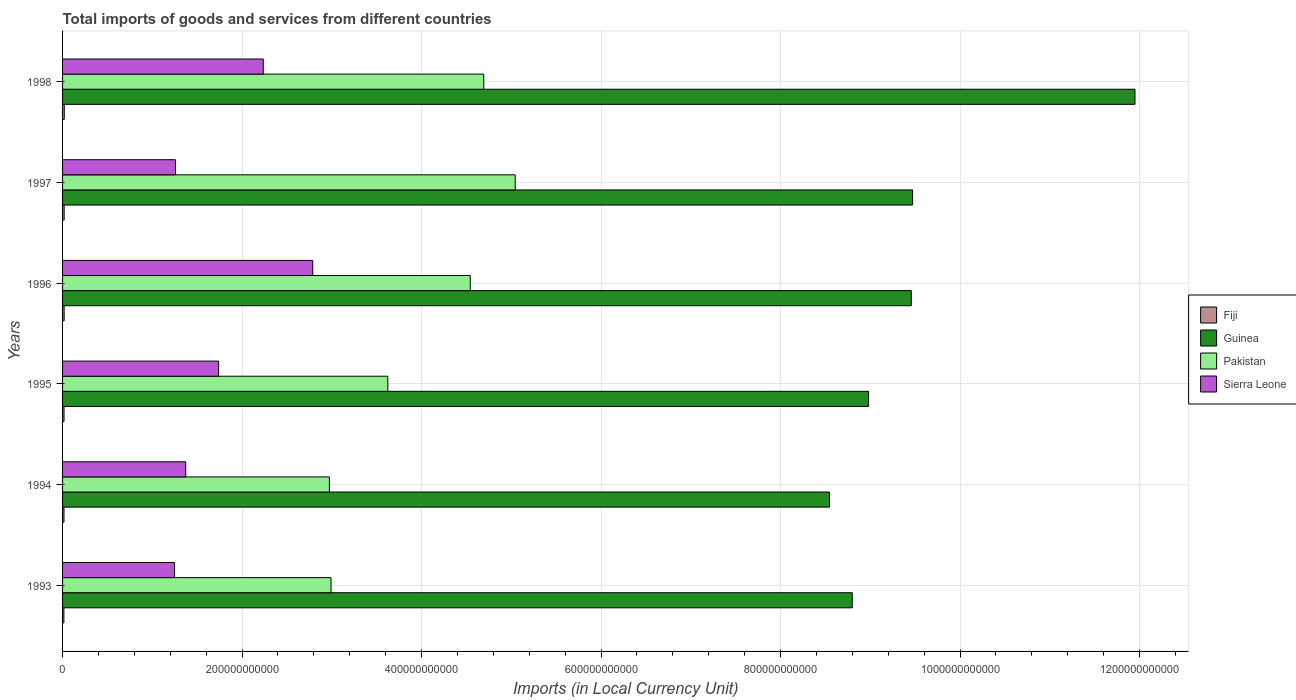How many different coloured bars are there?
Offer a terse response. 4. How many groups of bars are there?
Your response must be concise. 6. Are the number of bars per tick equal to the number of legend labels?
Offer a very short reply. Yes. Are the number of bars on each tick of the Y-axis equal?
Your answer should be compact. Yes. How many bars are there on the 1st tick from the bottom?
Make the answer very short. 4. What is the label of the 1st group of bars from the top?
Keep it short and to the point. 1998. In how many cases, is the number of bars for a given year not equal to the number of legend labels?
Keep it short and to the point. 0. What is the Amount of goods and services imports in Fiji in 1994?
Offer a very short reply. 1.59e+09. Across all years, what is the maximum Amount of goods and services imports in Sierra Leone?
Offer a very short reply. 2.79e+11. Across all years, what is the minimum Amount of goods and services imports in Sierra Leone?
Offer a terse response. 1.25e+11. What is the total Amount of goods and services imports in Pakistan in the graph?
Offer a terse response. 2.39e+12. What is the difference between the Amount of goods and services imports in Fiji in 1996 and that in 1998?
Provide a succinct answer. -1.61e+08. What is the difference between the Amount of goods and services imports in Pakistan in 1993 and the Amount of goods and services imports in Guinea in 1994?
Offer a very short reply. -5.55e+11. What is the average Amount of goods and services imports in Fiji per year?
Keep it short and to the point. 1.69e+09. In the year 1995, what is the difference between the Amount of goods and services imports in Fiji and Amount of goods and services imports in Guinea?
Make the answer very short. -8.96e+11. What is the ratio of the Amount of goods and services imports in Guinea in 1997 to that in 1998?
Offer a terse response. 0.79. Is the difference between the Amount of goods and services imports in Fiji in 1996 and 1998 greater than the difference between the Amount of goods and services imports in Guinea in 1996 and 1998?
Ensure brevity in your answer.  Yes. What is the difference between the highest and the second highest Amount of goods and services imports in Guinea?
Your answer should be very brief. 2.48e+11. What is the difference between the highest and the lowest Amount of goods and services imports in Guinea?
Ensure brevity in your answer.  3.40e+11. Is the sum of the Amount of goods and services imports in Pakistan in 1994 and 1995 greater than the maximum Amount of goods and services imports in Fiji across all years?
Offer a terse response. Yes. What does the 2nd bar from the top in 1994 represents?
Give a very brief answer. Pakistan. What does the 1st bar from the bottom in 1995 represents?
Offer a very short reply. Fiji. Are all the bars in the graph horizontal?
Ensure brevity in your answer.  Yes. How many years are there in the graph?
Your answer should be compact. 6. What is the difference between two consecutive major ticks on the X-axis?
Offer a very short reply. 2.00e+11. Does the graph contain any zero values?
Offer a very short reply. No. How many legend labels are there?
Provide a succinct answer. 4. How are the legend labels stacked?
Your response must be concise. Vertical. What is the title of the graph?
Ensure brevity in your answer.  Total imports of goods and services from different countries. What is the label or title of the X-axis?
Provide a short and direct response. Imports (in Local Currency Unit). What is the label or title of the Y-axis?
Provide a succinct answer. Years. What is the Imports (in Local Currency Unit) in Fiji in 1993?
Keep it short and to the point. 1.50e+09. What is the Imports (in Local Currency Unit) of Guinea in 1993?
Your response must be concise. 8.80e+11. What is the Imports (in Local Currency Unit) of Pakistan in 1993?
Keep it short and to the point. 2.99e+11. What is the Imports (in Local Currency Unit) in Sierra Leone in 1993?
Keep it short and to the point. 1.25e+11. What is the Imports (in Local Currency Unit) in Fiji in 1994?
Your response must be concise. 1.59e+09. What is the Imports (in Local Currency Unit) in Guinea in 1994?
Provide a short and direct response. 8.55e+11. What is the Imports (in Local Currency Unit) in Pakistan in 1994?
Your answer should be compact. 2.97e+11. What is the Imports (in Local Currency Unit) in Sierra Leone in 1994?
Your answer should be very brief. 1.37e+11. What is the Imports (in Local Currency Unit) of Fiji in 1995?
Give a very brief answer. 1.63e+09. What is the Imports (in Local Currency Unit) of Guinea in 1995?
Provide a short and direct response. 8.98e+11. What is the Imports (in Local Currency Unit) of Pakistan in 1995?
Your response must be concise. 3.62e+11. What is the Imports (in Local Currency Unit) of Sierra Leone in 1995?
Provide a succinct answer. 1.74e+11. What is the Imports (in Local Currency Unit) in Fiji in 1996?
Offer a very short reply. 1.76e+09. What is the Imports (in Local Currency Unit) in Guinea in 1996?
Provide a succinct answer. 9.46e+11. What is the Imports (in Local Currency Unit) of Pakistan in 1996?
Provide a succinct answer. 4.54e+11. What is the Imports (in Local Currency Unit) in Sierra Leone in 1996?
Your answer should be compact. 2.79e+11. What is the Imports (in Local Currency Unit) of Fiji in 1997?
Provide a succinct answer. 1.77e+09. What is the Imports (in Local Currency Unit) of Guinea in 1997?
Your answer should be compact. 9.47e+11. What is the Imports (in Local Currency Unit) of Pakistan in 1997?
Offer a terse response. 5.04e+11. What is the Imports (in Local Currency Unit) of Sierra Leone in 1997?
Provide a succinct answer. 1.26e+11. What is the Imports (in Local Currency Unit) in Fiji in 1998?
Provide a short and direct response. 1.92e+09. What is the Imports (in Local Currency Unit) in Guinea in 1998?
Your response must be concise. 1.19e+12. What is the Imports (in Local Currency Unit) in Pakistan in 1998?
Your answer should be very brief. 4.69e+11. What is the Imports (in Local Currency Unit) of Sierra Leone in 1998?
Your answer should be very brief. 2.24e+11. Across all years, what is the maximum Imports (in Local Currency Unit) in Fiji?
Keep it short and to the point. 1.92e+09. Across all years, what is the maximum Imports (in Local Currency Unit) of Guinea?
Provide a short and direct response. 1.19e+12. Across all years, what is the maximum Imports (in Local Currency Unit) in Pakistan?
Your response must be concise. 5.04e+11. Across all years, what is the maximum Imports (in Local Currency Unit) in Sierra Leone?
Keep it short and to the point. 2.79e+11. Across all years, what is the minimum Imports (in Local Currency Unit) in Fiji?
Your response must be concise. 1.50e+09. Across all years, what is the minimum Imports (in Local Currency Unit) of Guinea?
Your response must be concise. 8.55e+11. Across all years, what is the minimum Imports (in Local Currency Unit) of Pakistan?
Provide a short and direct response. 2.97e+11. Across all years, what is the minimum Imports (in Local Currency Unit) of Sierra Leone?
Your response must be concise. 1.25e+11. What is the total Imports (in Local Currency Unit) in Fiji in the graph?
Make the answer very short. 1.02e+1. What is the total Imports (in Local Currency Unit) of Guinea in the graph?
Your response must be concise. 5.72e+12. What is the total Imports (in Local Currency Unit) of Pakistan in the graph?
Provide a succinct answer. 2.39e+12. What is the total Imports (in Local Currency Unit) in Sierra Leone in the graph?
Make the answer very short. 1.06e+12. What is the difference between the Imports (in Local Currency Unit) in Fiji in 1993 and that in 1994?
Ensure brevity in your answer.  -8.98e+07. What is the difference between the Imports (in Local Currency Unit) in Guinea in 1993 and that in 1994?
Offer a very short reply. 2.54e+1. What is the difference between the Imports (in Local Currency Unit) in Pakistan in 1993 and that in 1994?
Offer a terse response. 1.84e+09. What is the difference between the Imports (in Local Currency Unit) of Sierra Leone in 1993 and that in 1994?
Your response must be concise. -1.25e+1. What is the difference between the Imports (in Local Currency Unit) of Fiji in 1993 and that in 1995?
Offer a terse response. -1.32e+08. What is the difference between the Imports (in Local Currency Unit) in Guinea in 1993 and that in 1995?
Provide a succinct answer. -1.82e+1. What is the difference between the Imports (in Local Currency Unit) in Pakistan in 1993 and that in 1995?
Provide a short and direct response. -6.33e+1. What is the difference between the Imports (in Local Currency Unit) in Sierra Leone in 1993 and that in 1995?
Provide a short and direct response. -4.92e+1. What is the difference between the Imports (in Local Currency Unit) of Fiji in 1993 and that in 1996?
Your response must be concise. -2.59e+08. What is the difference between the Imports (in Local Currency Unit) in Guinea in 1993 and that in 1996?
Your response must be concise. -6.58e+1. What is the difference between the Imports (in Local Currency Unit) in Pakistan in 1993 and that in 1996?
Provide a succinct answer. -1.55e+11. What is the difference between the Imports (in Local Currency Unit) of Sierra Leone in 1993 and that in 1996?
Your answer should be compact. -1.54e+11. What is the difference between the Imports (in Local Currency Unit) of Fiji in 1993 and that in 1997?
Make the answer very short. -2.68e+08. What is the difference between the Imports (in Local Currency Unit) in Guinea in 1993 and that in 1997?
Your answer should be compact. -6.72e+1. What is the difference between the Imports (in Local Currency Unit) of Pakistan in 1993 and that in 1997?
Your response must be concise. -2.05e+11. What is the difference between the Imports (in Local Currency Unit) of Sierra Leone in 1993 and that in 1997?
Ensure brevity in your answer.  -1.14e+09. What is the difference between the Imports (in Local Currency Unit) in Fiji in 1993 and that in 1998?
Your answer should be very brief. -4.20e+08. What is the difference between the Imports (in Local Currency Unit) in Guinea in 1993 and that in 1998?
Your answer should be very brief. -3.15e+11. What is the difference between the Imports (in Local Currency Unit) of Pakistan in 1993 and that in 1998?
Offer a very short reply. -1.70e+11. What is the difference between the Imports (in Local Currency Unit) of Sierra Leone in 1993 and that in 1998?
Your answer should be compact. -9.89e+1. What is the difference between the Imports (in Local Currency Unit) of Fiji in 1994 and that in 1995?
Give a very brief answer. -4.18e+07. What is the difference between the Imports (in Local Currency Unit) in Guinea in 1994 and that in 1995?
Your answer should be very brief. -4.36e+1. What is the difference between the Imports (in Local Currency Unit) in Pakistan in 1994 and that in 1995?
Provide a short and direct response. -6.51e+1. What is the difference between the Imports (in Local Currency Unit) of Sierra Leone in 1994 and that in 1995?
Your response must be concise. -3.66e+1. What is the difference between the Imports (in Local Currency Unit) in Fiji in 1994 and that in 1996?
Offer a terse response. -1.70e+08. What is the difference between the Imports (in Local Currency Unit) of Guinea in 1994 and that in 1996?
Give a very brief answer. -9.12e+1. What is the difference between the Imports (in Local Currency Unit) in Pakistan in 1994 and that in 1996?
Offer a terse response. -1.57e+11. What is the difference between the Imports (in Local Currency Unit) of Sierra Leone in 1994 and that in 1996?
Make the answer very short. -1.42e+11. What is the difference between the Imports (in Local Currency Unit) in Fiji in 1994 and that in 1997?
Make the answer very short. -1.78e+08. What is the difference between the Imports (in Local Currency Unit) in Guinea in 1994 and that in 1997?
Keep it short and to the point. -9.26e+1. What is the difference between the Imports (in Local Currency Unit) of Pakistan in 1994 and that in 1997?
Your response must be concise. -2.07e+11. What is the difference between the Imports (in Local Currency Unit) in Sierra Leone in 1994 and that in 1997?
Make the answer very short. 1.14e+1. What is the difference between the Imports (in Local Currency Unit) in Fiji in 1994 and that in 1998?
Your answer should be compact. -3.30e+08. What is the difference between the Imports (in Local Currency Unit) in Guinea in 1994 and that in 1998?
Your answer should be compact. -3.40e+11. What is the difference between the Imports (in Local Currency Unit) in Pakistan in 1994 and that in 1998?
Offer a very short reply. -1.72e+11. What is the difference between the Imports (in Local Currency Unit) of Sierra Leone in 1994 and that in 1998?
Make the answer very short. -8.64e+1. What is the difference between the Imports (in Local Currency Unit) in Fiji in 1995 and that in 1996?
Make the answer very short. -1.28e+08. What is the difference between the Imports (in Local Currency Unit) in Guinea in 1995 and that in 1996?
Make the answer very short. -4.76e+1. What is the difference between the Imports (in Local Currency Unit) of Pakistan in 1995 and that in 1996?
Offer a terse response. -9.19e+1. What is the difference between the Imports (in Local Currency Unit) of Sierra Leone in 1995 and that in 1996?
Offer a very short reply. -1.05e+11. What is the difference between the Imports (in Local Currency Unit) in Fiji in 1995 and that in 1997?
Your answer should be compact. -1.36e+08. What is the difference between the Imports (in Local Currency Unit) in Guinea in 1995 and that in 1997?
Provide a short and direct response. -4.90e+1. What is the difference between the Imports (in Local Currency Unit) of Pakistan in 1995 and that in 1997?
Offer a terse response. -1.42e+11. What is the difference between the Imports (in Local Currency Unit) in Sierra Leone in 1995 and that in 1997?
Your answer should be very brief. 4.80e+1. What is the difference between the Imports (in Local Currency Unit) of Fiji in 1995 and that in 1998?
Your answer should be compact. -2.89e+08. What is the difference between the Imports (in Local Currency Unit) of Guinea in 1995 and that in 1998?
Provide a short and direct response. -2.97e+11. What is the difference between the Imports (in Local Currency Unit) in Pakistan in 1995 and that in 1998?
Give a very brief answer. -1.07e+11. What is the difference between the Imports (in Local Currency Unit) of Sierra Leone in 1995 and that in 1998?
Your answer should be compact. -4.98e+1. What is the difference between the Imports (in Local Currency Unit) of Fiji in 1996 and that in 1997?
Keep it short and to the point. -8.40e+06. What is the difference between the Imports (in Local Currency Unit) in Guinea in 1996 and that in 1997?
Offer a very short reply. -1.47e+09. What is the difference between the Imports (in Local Currency Unit) of Pakistan in 1996 and that in 1997?
Your answer should be very brief. -5.01e+1. What is the difference between the Imports (in Local Currency Unit) of Sierra Leone in 1996 and that in 1997?
Provide a succinct answer. 1.53e+11. What is the difference between the Imports (in Local Currency Unit) in Fiji in 1996 and that in 1998?
Keep it short and to the point. -1.61e+08. What is the difference between the Imports (in Local Currency Unit) in Guinea in 1996 and that in 1998?
Your response must be concise. -2.49e+11. What is the difference between the Imports (in Local Currency Unit) in Pakistan in 1996 and that in 1998?
Keep it short and to the point. -1.50e+1. What is the difference between the Imports (in Local Currency Unit) in Sierra Leone in 1996 and that in 1998?
Give a very brief answer. 5.51e+1. What is the difference between the Imports (in Local Currency Unit) of Fiji in 1997 and that in 1998?
Provide a succinct answer. -1.52e+08. What is the difference between the Imports (in Local Currency Unit) in Guinea in 1997 and that in 1998?
Offer a very short reply. -2.48e+11. What is the difference between the Imports (in Local Currency Unit) of Pakistan in 1997 and that in 1998?
Ensure brevity in your answer.  3.51e+1. What is the difference between the Imports (in Local Currency Unit) in Sierra Leone in 1997 and that in 1998?
Ensure brevity in your answer.  -9.78e+1. What is the difference between the Imports (in Local Currency Unit) of Fiji in 1993 and the Imports (in Local Currency Unit) of Guinea in 1994?
Give a very brief answer. -8.53e+11. What is the difference between the Imports (in Local Currency Unit) of Fiji in 1993 and the Imports (in Local Currency Unit) of Pakistan in 1994?
Your answer should be very brief. -2.96e+11. What is the difference between the Imports (in Local Currency Unit) in Fiji in 1993 and the Imports (in Local Currency Unit) in Sierra Leone in 1994?
Keep it short and to the point. -1.36e+11. What is the difference between the Imports (in Local Currency Unit) in Guinea in 1993 and the Imports (in Local Currency Unit) in Pakistan in 1994?
Ensure brevity in your answer.  5.83e+11. What is the difference between the Imports (in Local Currency Unit) in Guinea in 1993 and the Imports (in Local Currency Unit) in Sierra Leone in 1994?
Your response must be concise. 7.43e+11. What is the difference between the Imports (in Local Currency Unit) in Pakistan in 1993 and the Imports (in Local Currency Unit) in Sierra Leone in 1994?
Your response must be concise. 1.62e+11. What is the difference between the Imports (in Local Currency Unit) in Fiji in 1993 and the Imports (in Local Currency Unit) in Guinea in 1995?
Provide a succinct answer. -8.97e+11. What is the difference between the Imports (in Local Currency Unit) in Fiji in 1993 and the Imports (in Local Currency Unit) in Pakistan in 1995?
Provide a succinct answer. -3.61e+11. What is the difference between the Imports (in Local Currency Unit) in Fiji in 1993 and the Imports (in Local Currency Unit) in Sierra Leone in 1995?
Make the answer very short. -1.72e+11. What is the difference between the Imports (in Local Currency Unit) in Guinea in 1993 and the Imports (in Local Currency Unit) in Pakistan in 1995?
Your response must be concise. 5.17e+11. What is the difference between the Imports (in Local Currency Unit) in Guinea in 1993 and the Imports (in Local Currency Unit) in Sierra Leone in 1995?
Your answer should be compact. 7.06e+11. What is the difference between the Imports (in Local Currency Unit) in Pakistan in 1993 and the Imports (in Local Currency Unit) in Sierra Leone in 1995?
Make the answer very short. 1.25e+11. What is the difference between the Imports (in Local Currency Unit) in Fiji in 1993 and the Imports (in Local Currency Unit) in Guinea in 1996?
Give a very brief answer. -9.44e+11. What is the difference between the Imports (in Local Currency Unit) of Fiji in 1993 and the Imports (in Local Currency Unit) of Pakistan in 1996?
Offer a terse response. -4.53e+11. What is the difference between the Imports (in Local Currency Unit) of Fiji in 1993 and the Imports (in Local Currency Unit) of Sierra Leone in 1996?
Provide a short and direct response. -2.77e+11. What is the difference between the Imports (in Local Currency Unit) of Guinea in 1993 and the Imports (in Local Currency Unit) of Pakistan in 1996?
Your answer should be very brief. 4.26e+11. What is the difference between the Imports (in Local Currency Unit) in Guinea in 1993 and the Imports (in Local Currency Unit) in Sierra Leone in 1996?
Provide a succinct answer. 6.01e+11. What is the difference between the Imports (in Local Currency Unit) of Pakistan in 1993 and the Imports (in Local Currency Unit) of Sierra Leone in 1996?
Give a very brief answer. 2.04e+1. What is the difference between the Imports (in Local Currency Unit) of Fiji in 1993 and the Imports (in Local Currency Unit) of Guinea in 1997?
Your answer should be very brief. -9.46e+11. What is the difference between the Imports (in Local Currency Unit) of Fiji in 1993 and the Imports (in Local Currency Unit) of Pakistan in 1997?
Keep it short and to the point. -5.03e+11. What is the difference between the Imports (in Local Currency Unit) in Fiji in 1993 and the Imports (in Local Currency Unit) in Sierra Leone in 1997?
Give a very brief answer. -1.24e+11. What is the difference between the Imports (in Local Currency Unit) in Guinea in 1993 and the Imports (in Local Currency Unit) in Pakistan in 1997?
Offer a very short reply. 3.76e+11. What is the difference between the Imports (in Local Currency Unit) of Guinea in 1993 and the Imports (in Local Currency Unit) of Sierra Leone in 1997?
Keep it short and to the point. 7.54e+11. What is the difference between the Imports (in Local Currency Unit) in Pakistan in 1993 and the Imports (in Local Currency Unit) in Sierra Leone in 1997?
Keep it short and to the point. 1.73e+11. What is the difference between the Imports (in Local Currency Unit) of Fiji in 1993 and the Imports (in Local Currency Unit) of Guinea in 1998?
Keep it short and to the point. -1.19e+12. What is the difference between the Imports (in Local Currency Unit) in Fiji in 1993 and the Imports (in Local Currency Unit) in Pakistan in 1998?
Offer a very short reply. -4.68e+11. What is the difference between the Imports (in Local Currency Unit) of Fiji in 1993 and the Imports (in Local Currency Unit) of Sierra Leone in 1998?
Give a very brief answer. -2.22e+11. What is the difference between the Imports (in Local Currency Unit) of Guinea in 1993 and the Imports (in Local Currency Unit) of Pakistan in 1998?
Your answer should be compact. 4.11e+11. What is the difference between the Imports (in Local Currency Unit) in Guinea in 1993 and the Imports (in Local Currency Unit) in Sierra Leone in 1998?
Offer a terse response. 6.56e+11. What is the difference between the Imports (in Local Currency Unit) of Pakistan in 1993 and the Imports (in Local Currency Unit) of Sierra Leone in 1998?
Your answer should be very brief. 7.55e+1. What is the difference between the Imports (in Local Currency Unit) in Fiji in 1994 and the Imports (in Local Currency Unit) in Guinea in 1995?
Keep it short and to the point. -8.97e+11. What is the difference between the Imports (in Local Currency Unit) of Fiji in 1994 and the Imports (in Local Currency Unit) of Pakistan in 1995?
Offer a terse response. -3.61e+11. What is the difference between the Imports (in Local Currency Unit) in Fiji in 1994 and the Imports (in Local Currency Unit) in Sierra Leone in 1995?
Provide a succinct answer. -1.72e+11. What is the difference between the Imports (in Local Currency Unit) of Guinea in 1994 and the Imports (in Local Currency Unit) of Pakistan in 1995?
Provide a succinct answer. 4.92e+11. What is the difference between the Imports (in Local Currency Unit) of Guinea in 1994 and the Imports (in Local Currency Unit) of Sierra Leone in 1995?
Your answer should be very brief. 6.81e+11. What is the difference between the Imports (in Local Currency Unit) of Pakistan in 1994 and the Imports (in Local Currency Unit) of Sierra Leone in 1995?
Your response must be concise. 1.23e+11. What is the difference between the Imports (in Local Currency Unit) in Fiji in 1994 and the Imports (in Local Currency Unit) in Guinea in 1996?
Keep it short and to the point. -9.44e+11. What is the difference between the Imports (in Local Currency Unit) of Fiji in 1994 and the Imports (in Local Currency Unit) of Pakistan in 1996?
Offer a very short reply. -4.53e+11. What is the difference between the Imports (in Local Currency Unit) in Fiji in 1994 and the Imports (in Local Currency Unit) in Sierra Leone in 1996?
Make the answer very short. -2.77e+11. What is the difference between the Imports (in Local Currency Unit) of Guinea in 1994 and the Imports (in Local Currency Unit) of Pakistan in 1996?
Your answer should be compact. 4.00e+11. What is the difference between the Imports (in Local Currency Unit) in Guinea in 1994 and the Imports (in Local Currency Unit) in Sierra Leone in 1996?
Your answer should be compact. 5.76e+11. What is the difference between the Imports (in Local Currency Unit) of Pakistan in 1994 and the Imports (in Local Currency Unit) of Sierra Leone in 1996?
Make the answer very short. 1.85e+1. What is the difference between the Imports (in Local Currency Unit) in Fiji in 1994 and the Imports (in Local Currency Unit) in Guinea in 1997?
Offer a very short reply. -9.46e+11. What is the difference between the Imports (in Local Currency Unit) of Fiji in 1994 and the Imports (in Local Currency Unit) of Pakistan in 1997?
Provide a short and direct response. -5.03e+11. What is the difference between the Imports (in Local Currency Unit) of Fiji in 1994 and the Imports (in Local Currency Unit) of Sierra Leone in 1997?
Give a very brief answer. -1.24e+11. What is the difference between the Imports (in Local Currency Unit) of Guinea in 1994 and the Imports (in Local Currency Unit) of Pakistan in 1997?
Ensure brevity in your answer.  3.50e+11. What is the difference between the Imports (in Local Currency Unit) in Guinea in 1994 and the Imports (in Local Currency Unit) in Sierra Leone in 1997?
Your response must be concise. 7.29e+11. What is the difference between the Imports (in Local Currency Unit) in Pakistan in 1994 and the Imports (in Local Currency Unit) in Sierra Leone in 1997?
Offer a very short reply. 1.71e+11. What is the difference between the Imports (in Local Currency Unit) of Fiji in 1994 and the Imports (in Local Currency Unit) of Guinea in 1998?
Offer a terse response. -1.19e+12. What is the difference between the Imports (in Local Currency Unit) of Fiji in 1994 and the Imports (in Local Currency Unit) of Pakistan in 1998?
Give a very brief answer. -4.68e+11. What is the difference between the Imports (in Local Currency Unit) of Fiji in 1994 and the Imports (in Local Currency Unit) of Sierra Leone in 1998?
Offer a very short reply. -2.22e+11. What is the difference between the Imports (in Local Currency Unit) of Guinea in 1994 and the Imports (in Local Currency Unit) of Pakistan in 1998?
Offer a very short reply. 3.85e+11. What is the difference between the Imports (in Local Currency Unit) in Guinea in 1994 and the Imports (in Local Currency Unit) in Sierra Leone in 1998?
Your response must be concise. 6.31e+11. What is the difference between the Imports (in Local Currency Unit) in Pakistan in 1994 and the Imports (in Local Currency Unit) in Sierra Leone in 1998?
Give a very brief answer. 7.37e+1. What is the difference between the Imports (in Local Currency Unit) of Fiji in 1995 and the Imports (in Local Currency Unit) of Guinea in 1996?
Your response must be concise. -9.44e+11. What is the difference between the Imports (in Local Currency Unit) in Fiji in 1995 and the Imports (in Local Currency Unit) in Pakistan in 1996?
Make the answer very short. -4.53e+11. What is the difference between the Imports (in Local Currency Unit) in Fiji in 1995 and the Imports (in Local Currency Unit) in Sierra Leone in 1996?
Offer a terse response. -2.77e+11. What is the difference between the Imports (in Local Currency Unit) in Guinea in 1995 and the Imports (in Local Currency Unit) in Pakistan in 1996?
Offer a very short reply. 4.44e+11. What is the difference between the Imports (in Local Currency Unit) of Guinea in 1995 and the Imports (in Local Currency Unit) of Sierra Leone in 1996?
Ensure brevity in your answer.  6.19e+11. What is the difference between the Imports (in Local Currency Unit) in Pakistan in 1995 and the Imports (in Local Currency Unit) in Sierra Leone in 1996?
Offer a very short reply. 8.37e+1. What is the difference between the Imports (in Local Currency Unit) of Fiji in 1995 and the Imports (in Local Currency Unit) of Guinea in 1997?
Your response must be concise. -9.46e+11. What is the difference between the Imports (in Local Currency Unit) in Fiji in 1995 and the Imports (in Local Currency Unit) in Pakistan in 1997?
Ensure brevity in your answer.  -5.03e+11. What is the difference between the Imports (in Local Currency Unit) of Fiji in 1995 and the Imports (in Local Currency Unit) of Sierra Leone in 1997?
Give a very brief answer. -1.24e+11. What is the difference between the Imports (in Local Currency Unit) in Guinea in 1995 and the Imports (in Local Currency Unit) in Pakistan in 1997?
Provide a short and direct response. 3.94e+11. What is the difference between the Imports (in Local Currency Unit) in Guinea in 1995 and the Imports (in Local Currency Unit) in Sierra Leone in 1997?
Keep it short and to the point. 7.72e+11. What is the difference between the Imports (in Local Currency Unit) of Pakistan in 1995 and the Imports (in Local Currency Unit) of Sierra Leone in 1997?
Ensure brevity in your answer.  2.37e+11. What is the difference between the Imports (in Local Currency Unit) of Fiji in 1995 and the Imports (in Local Currency Unit) of Guinea in 1998?
Keep it short and to the point. -1.19e+12. What is the difference between the Imports (in Local Currency Unit) in Fiji in 1995 and the Imports (in Local Currency Unit) in Pakistan in 1998?
Provide a succinct answer. -4.68e+11. What is the difference between the Imports (in Local Currency Unit) of Fiji in 1995 and the Imports (in Local Currency Unit) of Sierra Leone in 1998?
Ensure brevity in your answer.  -2.22e+11. What is the difference between the Imports (in Local Currency Unit) in Guinea in 1995 and the Imports (in Local Currency Unit) in Pakistan in 1998?
Give a very brief answer. 4.29e+11. What is the difference between the Imports (in Local Currency Unit) of Guinea in 1995 and the Imports (in Local Currency Unit) of Sierra Leone in 1998?
Offer a very short reply. 6.74e+11. What is the difference between the Imports (in Local Currency Unit) in Pakistan in 1995 and the Imports (in Local Currency Unit) in Sierra Leone in 1998?
Ensure brevity in your answer.  1.39e+11. What is the difference between the Imports (in Local Currency Unit) in Fiji in 1996 and the Imports (in Local Currency Unit) in Guinea in 1997?
Keep it short and to the point. -9.45e+11. What is the difference between the Imports (in Local Currency Unit) in Fiji in 1996 and the Imports (in Local Currency Unit) in Pakistan in 1997?
Your answer should be very brief. -5.03e+11. What is the difference between the Imports (in Local Currency Unit) in Fiji in 1996 and the Imports (in Local Currency Unit) in Sierra Leone in 1997?
Provide a succinct answer. -1.24e+11. What is the difference between the Imports (in Local Currency Unit) in Guinea in 1996 and the Imports (in Local Currency Unit) in Pakistan in 1997?
Provide a short and direct response. 4.41e+11. What is the difference between the Imports (in Local Currency Unit) in Guinea in 1996 and the Imports (in Local Currency Unit) in Sierra Leone in 1997?
Offer a terse response. 8.20e+11. What is the difference between the Imports (in Local Currency Unit) of Pakistan in 1996 and the Imports (in Local Currency Unit) of Sierra Leone in 1997?
Your answer should be very brief. 3.28e+11. What is the difference between the Imports (in Local Currency Unit) of Fiji in 1996 and the Imports (in Local Currency Unit) of Guinea in 1998?
Ensure brevity in your answer.  -1.19e+12. What is the difference between the Imports (in Local Currency Unit) in Fiji in 1996 and the Imports (in Local Currency Unit) in Pakistan in 1998?
Provide a short and direct response. -4.68e+11. What is the difference between the Imports (in Local Currency Unit) in Fiji in 1996 and the Imports (in Local Currency Unit) in Sierra Leone in 1998?
Keep it short and to the point. -2.22e+11. What is the difference between the Imports (in Local Currency Unit) of Guinea in 1996 and the Imports (in Local Currency Unit) of Pakistan in 1998?
Ensure brevity in your answer.  4.76e+11. What is the difference between the Imports (in Local Currency Unit) of Guinea in 1996 and the Imports (in Local Currency Unit) of Sierra Leone in 1998?
Keep it short and to the point. 7.22e+11. What is the difference between the Imports (in Local Currency Unit) of Pakistan in 1996 and the Imports (in Local Currency Unit) of Sierra Leone in 1998?
Give a very brief answer. 2.31e+11. What is the difference between the Imports (in Local Currency Unit) of Fiji in 1997 and the Imports (in Local Currency Unit) of Guinea in 1998?
Give a very brief answer. -1.19e+12. What is the difference between the Imports (in Local Currency Unit) in Fiji in 1997 and the Imports (in Local Currency Unit) in Pakistan in 1998?
Your answer should be compact. -4.68e+11. What is the difference between the Imports (in Local Currency Unit) in Fiji in 1997 and the Imports (in Local Currency Unit) in Sierra Leone in 1998?
Offer a very short reply. -2.22e+11. What is the difference between the Imports (in Local Currency Unit) in Guinea in 1997 and the Imports (in Local Currency Unit) in Pakistan in 1998?
Your response must be concise. 4.78e+11. What is the difference between the Imports (in Local Currency Unit) of Guinea in 1997 and the Imports (in Local Currency Unit) of Sierra Leone in 1998?
Your response must be concise. 7.24e+11. What is the difference between the Imports (in Local Currency Unit) in Pakistan in 1997 and the Imports (in Local Currency Unit) in Sierra Leone in 1998?
Make the answer very short. 2.81e+11. What is the average Imports (in Local Currency Unit) in Fiji per year?
Keep it short and to the point. 1.69e+09. What is the average Imports (in Local Currency Unit) of Guinea per year?
Ensure brevity in your answer.  9.53e+11. What is the average Imports (in Local Currency Unit) in Pakistan per year?
Provide a succinct answer. 3.98e+11. What is the average Imports (in Local Currency Unit) of Sierra Leone per year?
Offer a very short reply. 1.77e+11. In the year 1993, what is the difference between the Imports (in Local Currency Unit) in Fiji and Imports (in Local Currency Unit) in Guinea?
Provide a short and direct response. -8.78e+11. In the year 1993, what is the difference between the Imports (in Local Currency Unit) in Fiji and Imports (in Local Currency Unit) in Pakistan?
Your response must be concise. -2.98e+11. In the year 1993, what is the difference between the Imports (in Local Currency Unit) of Fiji and Imports (in Local Currency Unit) of Sierra Leone?
Keep it short and to the point. -1.23e+11. In the year 1993, what is the difference between the Imports (in Local Currency Unit) in Guinea and Imports (in Local Currency Unit) in Pakistan?
Make the answer very short. 5.81e+11. In the year 1993, what is the difference between the Imports (in Local Currency Unit) in Guinea and Imports (in Local Currency Unit) in Sierra Leone?
Ensure brevity in your answer.  7.55e+11. In the year 1993, what is the difference between the Imports (in Local Currency Unit) of Pakistan and Imports (in Local Currency Unit) of Sierra Leone?
Your answer should be compact. 1.74e+11. In the year 1994, what is the difference between the Imports (in Local Currency Unit) of Fiji and Imports (in Local Currency Unit) of Guinea?
Ensure brevity in your answer.  -8.53e+11. In the year 1994, what is the difference between the Imports (in Local Currency Unit) in Fiji and Imports (in Local Currency Unit) in Pakistan?
Your answer should be compact. -2.96e+11. In the year 1994, what is the difference between the Imports (in Local Currency Unit) of Fiji and Imports (in Local Currency Unit) of Sierra Leone?
Your answer should be compact. -1.36e+11. In the year 1994, what is the difference between the Imports (in Local Currency Unit) in Guinea and Imports (in Local Currency Unit) in Pakistan?
Your answer should be compact. 5.57e+11. In the year 1994, what is the difference between the Imports (in Local Currency Unit) of Guinea and Imports (in Local Currency Unit) of Sierra Leone?
Provide a short and direct response. 7.17e+11. In the year 1994, what is the difference between the Imports (in Local Currency Unit) of Pakistan and Imports (in Local Currency Unit) of Sierra Leone?
Offer a terse response. 1.60e+11. In the year 1995, what is the difference between the Imports (in Local Currency Unit) of Fiji and Imports (in Local Currency Unit) of Guinea?
Keep it short and to the point. -8.96e+11. In the year 1995, what is the difference between the Imports (in Local Currency Unit) of Fiji and Imports (in Local Currency Unit) of Pakistan?
Provide a short and direct response. -3.61e+11. In the year 1995, what is the difference between the Imports (in Local Currency Unit) of Fiji and Imports (in Local Currency Unit) of Sierra Leone?
Your answer should be compact. -1.72e+11. In the year 1995, what is the difference between the Imports (in Local Currency Unit) in Guinea and Imports (in Local Currency Unit) in Pakistan?
Give a very brief answer. 5.36e+11. In the year 1995, what is the difference between the Imports (in Local Currency Unit) of Guinea and Imports (in Local Currency Unit) of Sierra Leone?
Keep it short and to the point. 7.24e+11. In the year 1995, what is the difference between the Imports (in Local Currency Unit) of Pakistan and Imports (in Local Currency Unit) of Sierra Leone?
Offer a very short reply. 1.89e+11. In the year 1996, what is the difference between the Imports (in Local Currency Unit) in Fiji and Imports (in Local Currency Unit) in Guinea?
Offer a very short reply. -9.44e+11. In the year 1996, what is the difference between the Imports (in Local Currency Unit) in Fiji and Imports (in Local Currency Unit) in Pakistan?
Keep it short and to the point. -4.53e+11. In the year 1996, what is the difference between the Imports (in Local Currency Unit) in Fiji and Imports (in Local Currency Unit) in Sierra Leone?
Keep it short and to the point. -2.77e+11. In the year 1996, what is the difference between the Imports (in Local Currency Unit) in Guinea and Imports (in Local Currency Unit) in Pakistan?
Your response must be concise. 4.91e+11. In the year 1996, what is the difference between the Imports (in Local Currency Unit) of Guinea and Imports (in Local Currency Unit) of Sierra Leone?
Your answer should be compact. 6.67e+11. In the year 1996, what is the difference between the Imports (in Local Currency Unit) in Pakistan and Imports (in Local Currency Unit) in Sierra Leone?
Offer a very short reply. 1.76e+11. In the year 1997, what is the difference between the Imports (in Local Currency Unit) of Fiji and Imports (in Local Currency Unit) of Guinea?
Your response must be concise. -9.45e+11. In the year 1997, what is the difference between the Imports (in Local Currency Unit) in Fiji and Imports (in Local Currency Unit) in Pakistan?
Make the answer very short. -5.03e+11. In the year 1997, what is the difference between the Imports (in Local Currency Unit) of Fiji and Imports (in Local Currency Unit) of Sierra Leone?
Offer a very short reply. -1.24e+11. In the year 1997, what is the difference between the Imports (in Local Currency Unit) in Guinea and Imports (in Local Currency Unit) in Pakistan?
Ensure brevity in your answer.  4.43e+11. In the year 1997, what is the difference between the Imports (in Local Currency Unit) in Guinea and Imports (in Local Currency Unit) in Sierra Leone?
Your answer should be compact. 8.21e+11. In the year 1997, what is the difference between the Imports (in Local Currency Unit) in Pakistan and Imports (in Local Currency Unit) in Sierra Leone?
Offer a very short reply. 3.79e+11. In the year 1998, what is the difference between the Imports (in Local Currency Unit) of Fiji and Imports (in Local Currency Unit) of Guinea?
Ensure brevity in your answer.  -1.19e+12. In the year 1998, what is the difference between the Imports (in Local Currency Unit) of Fiji and Imports (in Local Currency Unit) of Pakistan?
Offer a terse response. -4.67e+11. In the year 1998, what is the difference between the Imports (in Local Currency Unit) in Fiji and Imports (in Local Currency Unit) in Sierra Leone?
Give a very brief answer. -2.22e+11. In the year 1998, what is the difference between the Imports (in Local Currency Unit) in Guinea and Imports (in Local Currency Unit) in Pakistan?
Make the answer very short. 7.26e+11. In the year 1998, what is the difference between the Imports (in Local Currency Unit) in Guinea and Imports (in Local Currency Unit) in Sierra Leone?
Make the answer very short. 9.71e+11. In the year 1998, what is the difference between the Imports (in Local Currency Unit) of Pakistan and Imports (in Local Currency Unit) of Sierra Leone?
Keep it short and to the point. 2.46e+11. What is the ratio of the Imports (in Local Currency Unit) of Fiji in 1993 to that in 1994?
Offer a very short reply. 0.94. What is the ratio of the Imports (in Local Currency Unit) of Guinea in 1993 to that in 1994?
Offer a very short reply. 1.03. What is the ratio of the Imports (in Local Currency Unit) in Pakistan in 1993 to that in 1994?
Your answer should be very brief. 1.01. What is the ratio of the Imports (in Local Currency Unit) of Sierra Leone in 1993 to that in 1994?
Give a very brief answer. 0.91. What is the ratio of the Imports (in Local Currency Unit) in Fiji in 1993 to that in 1995?
Your answer should be very brief. 0.92. What is the ratio of the Imports (in Local Currency Unit) in Guinea in 1993 to that in 1995?
Ensure brevity in your answer.  0.98. What is the ratio of the Imports (in Local Currency Unit) of Pakistan in 1993 to that in 1995?
Keep it short and to the point. 0.83. What is the ratio of the Imports (in Local Currency Unit) of Sierra Leone in 1993 to that in 1995?
Your answer should be very brief. 0.72. What is the ratio of the Imports (in Local Currency Unit) in Fiji in 1993 to that in 1996?
Offer a terse response. 0.85. What is the ratio of the Imports (in Local Currency Unit) of Guinea in 1993 to that in 1996?
Make the answer very short. 0.93. What is the ratio of the Imports (in Local Currency Unit) of Pakistan in 1993 to that in 1996?
Offer a very short reply. 0.66. What is the ratio of the Imports (in Local Currency Unit) in Sierra Leone in 1993 to that in 1996?
Make the answer very short. 0.45. What is the ratio of the Imports (in Local Currency Unit) of Fiji in 1993 to that in 1997?
Offer a very short reply. 0.85. What is the ratio of the Imports (in Local Currency Unit) of Guinea in 1993 to that in 1997?
Offer a terse response. 0.93. What is the ratio of the Imports (in Local Currency Unit) of Pakistan in 1993 to that in 1997?
Provide a succinct answer. 0.59. What is the ratio of the Imports (in Local Currency Unit) of Sierra Leone in 1993 to that in 1997?
Offer a very short reply. 0.99. What is the ratio of the Imports (in Local Currency Unit) in Fiji in 1993 to that in 1998?
Provide a succinct answer. 0.78. What is the ratio of the Imports (in Local Currency Unit) in Guinea in 1993 to that in 1998?
Your answer should be compact. 0.74. What is the ratio of the Imports (in Local Currency Unit) in Pakistan in 1993 to that in 1998?
Provide a short and direct response. 0.64. What is the ratio of the Imports (in Local Currency Unit) of Sierra Leone in 1993 to that in 1998?
Give a very brief answer. 0.56. What is the ratio of the Imports (in Local Currency Unit) in Fiji in 1994 to that in 1995?
Offer a very short reply. 0.97. What is the ratio of the Imports (in Local Currency Unit) of Guinea in 1994 to that in 1995?
Your answer should be very brief. 0.95. What is the ratio of the Imports (in Local Currency Unit) in Pakistan in 1994 to that in 1995?
Offer a very short reply. 0.82. What is the ratio of the Imports (in Local Currency Unit) in Sierra Leone in 1994 to that in 1995?
Offer a terse response. 0.79. What is the ratio of the Imports (in Local Currency Unit) in Fiji in 1994 to that in 1996?
Give a very brief answer. 0.9. What is the ratio of the Imports (in Local Currency Unit) in Guinea in 1994 to that in 1996?
Offer a terse response. 0.9. What is the ratio of the Imports (in Local Currency Unit) of Pakistan in 1994 to that in 1996?
Give a very brief answer. 0.65. What is the ratio of the Imports (in Local Currency Unit) of Sierra Leone in 1994 to that in 1996?
Ensure brevity in your answer.  0.49. What is the ratio of the Imports (in Local Currency Unit) of Fiji in 1994 to that in 1997?
Offer a very short reply. 0.9. What is the ratio of the Imports (in Local Currency Unit) in Guinea in 1994 to that in 1997?
Provide a short and direct response. 0.9. What is the ratio of the Imports (in Local Currency Unit) in Pakistan in 1994 to that in 1997?
Offer a terse response. 0.59. What is the ratio of the Imports (in Local Currency Unit) of Sierra Leone in 1994 to that in 1997?
Make the answer very short. 1.09. What is the ratio of the Imports (in Local Currency Unit) in Fiji in 1994 to that in 1998?
Your response must be concise. 0.83. What is the ratio of the Imports (in Local Currency Unit) in Guinea in 1994 to that in 1998?
Offer a very short reply. 0.72. What is the ratio of the Imports (in Local Currency Unit) of Pakistan in 1994 to that in 1998?
Provide a short and direct response. 0.63. What is the ratio of the Imports (in Local Currency Unit) in Sierra Leone in 1994 to that in 1998?
Provide a short and direct response. 0.61. What is the ratio of the Imports (in Local Currency Unit) of Fiji in 1995 to that in 1996?
Make the answer very short. 0.93. What is the ratio of the Imports (in Local Currency Unit) in Guinea in 1995 to that in 1996?
Ensure brevity in your answer.  0.95. What is the ratio of the Imports (in Local Currency Unit) in Pakistan in 1995 to that in 1996?
Your response must be concise. 0.8. What is the ratio of the Imports (in Local Currency Unit) in Sierra Leone in 1995 to that in 1996?
Give a very brief answer. 0.62. What is the ratio of the Imports (in Local Currency Unit) of Fiji in 1995 to that in 1997?
Give a very brief answer. 0.92. What is the ratio of the Imports (in Local Currency Unit) in Guinea in 1995 to that in 1997?
Provide a short and direct response. 0.95. What is the ratio of the Imports (in Local Currency Unit) of Pakistan in 1995 to that in 1997?
Your answer should be compact. 0.72. What is the ratio of the Imports (in Local Currency Unit) of Sierra Leone in 1995 to that in 1997?
Your answer should be compact. 1.38. What is the ratio of the Imports (in Local Currency Unit) in Fiji in 1995 to that in 1998?
Offer a terse response. 0.85. What is the ratio of the Imports (in Local Currency Unit) in Guinea in 1995 to that in 1998?
Your answer should be very brief. 0.75. What is the ratio of the Imports (in Local Currency Unit) of Pakistan in 1995 to that in 1998?
Your answer should be compact. 0.77. What is the ratio of the Imports (in Local Currency Unit) of Sierra Leone in 1995 to that in 1998?
Keep it short and to the point. 0.78. What is the ratio of the Imports (in Local Currency Unit) of Guinea in 1996 to that in 1997?
Your answer should be very brief. 1. What is the ratio of the Imports (in Local Currency Unit) in Pakistan in 1996 to that in 1997?
Give a very brief answer. 0.9. What is the ratio of the Imports (in Local Currency Unit) in Sierra Leone in 1996 to that in 1997?
Your answer should be compact. 2.22. What is the ratio of the Imports (in Local Currency Unit) of Fiji in 1996 to that in 1998?
Provide a succinct answer. 0.92. What is the ratio of the Imports (in Local Currency Unit) of Guinea in 1996 to that in 1998?
Give a very brief answer. 0.79. What is the ratio of the Imports (in Local Currency Unit) of Sierra Leone in 1996 to that in 1998?
Keep it short and to the point. 1.25. What is the ratio of the Imports (in Local Currency Unit) in Fiji in 1997 to that in 1998?
Give a very brief answer. 0.92. What is the ratio of the Imports (in Local Currency Unit) of Guinea in 1997 to that in 1998?
Provide a succinct answer. 0.79. What is the ratio of the Imports (in Local Currency Unit) in Pakistan in 1997 to that in 1998?
Offer a very short reply. 1.07. What is the ratio of the Imports (in Local Currency Unit) of Sierra Leone in 1997 to that in 1998?
Offer a terse response. 0.56. What is the difference between the highest and the second highest Imports (in Local Currency Unit) of Fiji?
Offer a terse response. 1.52e+08. What is the difference between the highest and the second highest Imports (in Local Currency Unit) in Guinea?
Offer a terse response. 2.48e+11. What is the difference between the highest and the second highest Imports (in Local Currency Unit) in Pakistan?
Offer a terse response. 3.51e+1. What is the difference between the highest and the second highest Imports (in Local Currency Unit) of Sierra Leone?
Keep it short and to the point. 5.51e+1. What is the difference between the highest and the lowest Imports (in Local Currency Unit) in Fiji?
Your response must be concise. 4.20e+08. What is the difference between the highest and the lowest Imports (in Local Currency Unit) in Guinea?
Provide a succinct answer. 3.40e+11. What is the difference between the highest and the lowest Imports (in Local Currency Unit) in Pakistan?
Your answer should be very brief. 2.07e+11. What is the difference between the highest and the lowest Imports (in Local Currency Unit) of Sierra Leone?
Your answer should be compact. 1.54e+11. 